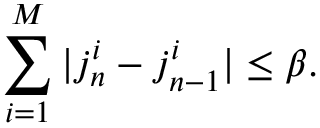<formula> <loc_0><loc_0><loc_500><loc_500>\sum _ { i = 1 } ^ { M } | j _ { n } ^ { i } - j _ { n - 1 } ^ { i } | \leq \beta .</formula> 